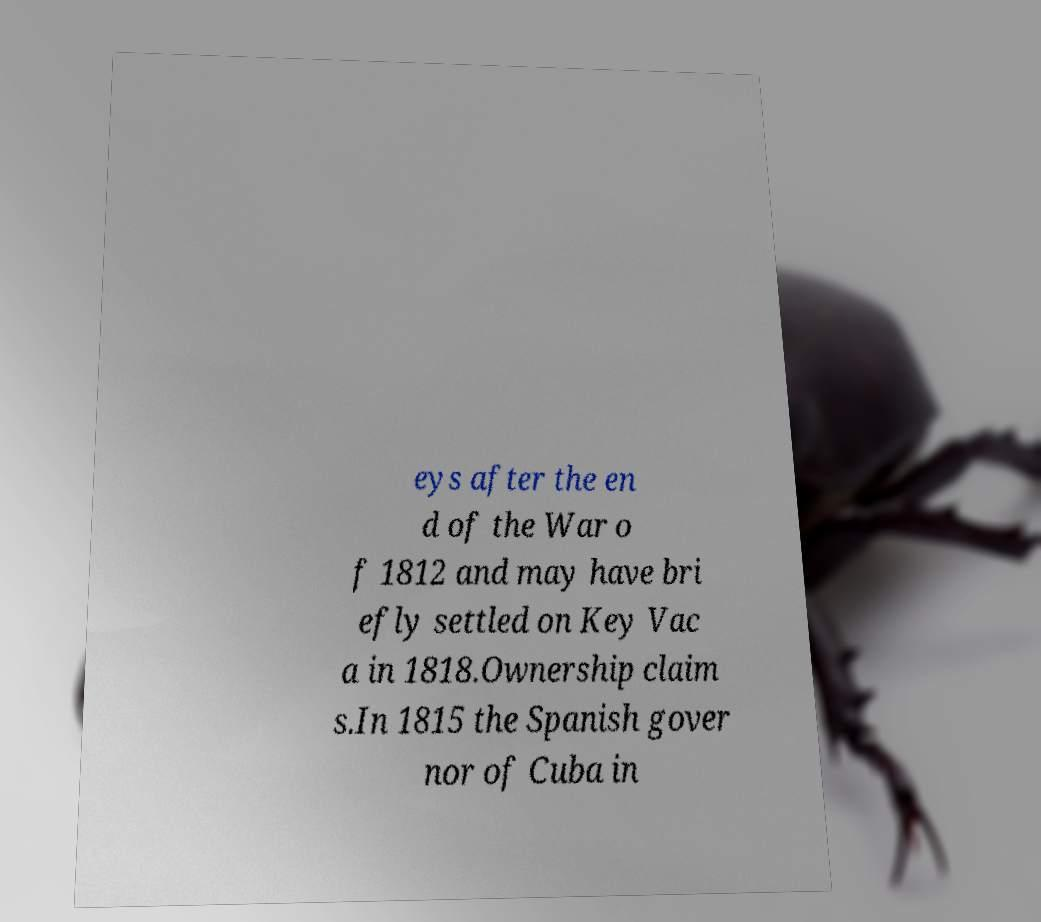What messages or text are displayed in this image? I need them in a readable, typed format. eys after the en d of the War o f 1812 and may have bri efly settled on Key Vac a in 1818.Ownership claim s.In 1815 the Spanish gover nor of Cuba in 